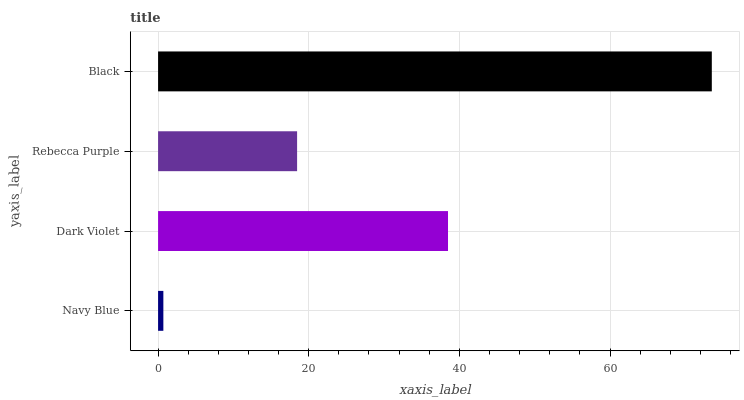Is Navy Blue the minimum?
Answer yes or no. Yes. Is Black the maximum?
Answer yes or no. Yes. Is Dark Violet the minimum?
Answer yes or no. No. Is Dark Violet the maximum?
Answer yes or no. No. Is Dark Violet greater than Navy Blue?
Answer yes or no. Yes. Is Navy Blue less than Dark Violet?
Answer yes or no. Yes. Is Navy Blue greater than Dark Violet?
Answer yes or no. No. Is Dark Violet less than Navy Blue?
Answer yes or no. No. Is Dark Violet the high median?
Answer yes or no. Yes. Is Rebecca Purple the low median?
Answer yes or no. Yes. Is Rebecca Purple the high median?
Answer yes or no. No. Is Dark Violet the low median?
Answer yes or no. No. 